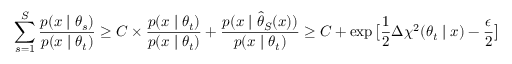<formula> <loc_0><loc_0><loc_500><loc_500>\sum _ { s = 1 } ^ { S } \frac { p ( x | \theta _ { s } ) } { p ( x | \theta _ { t } ) } \geq C \times \frac { p ( x | \theta _ { t } ) } { p ( x | \theta _ { t } ) } + \frac { p ( x | \hat { \theta } _ { S } ( x ) ) } { p ( x | \theta _ { t } ) } \geq C + \exp \left [ \frac { 1 } { 2 } \Delta \chi ^ { 2 } ( \theta _ { t } | x ) - \frac { \epsilon } { 2 } \right ]</formula> 